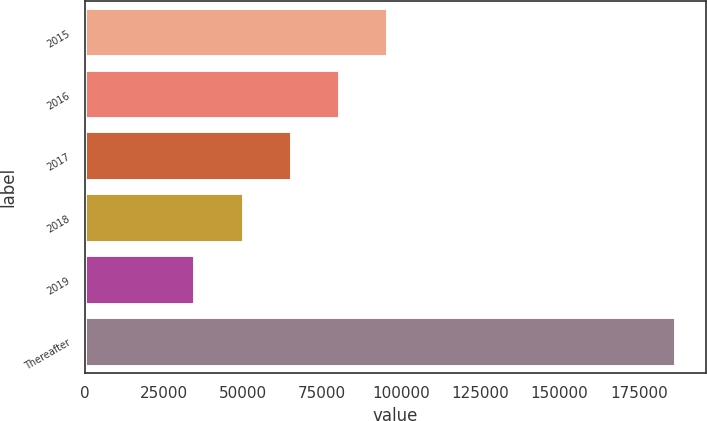<chart> <loc_0><loc_0><loc_500><loc_500><bar_chart><fcel>2015<fcel>2016<fcel>2017<fcel>2018<fcel>2019<fcel>Thereafter<nl><fcel>95669.8<fcel>80484.6<fcel>65299.4<fcel>50114.2<fcel>34929<fcel>186781<nl></chart> 